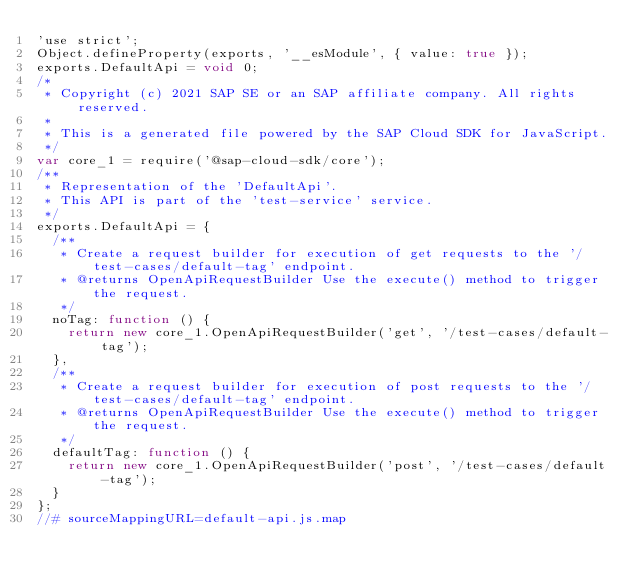Convert code to text. <code><loc_0><loc_0><loc_500><loc_500><_JavaScript_>'use strict';
Object.defineProperty(exports, '__esModule', { value: true });
exports.DefaultApi = void 0;
/*
 * Copyright (c) 2021 SAP SE or an SAP affiliate company. All rights reserved.
 *
 * This is a generated file powered by the SAP Cloud SDK for JavaScript.
 */
var core_1 = require('@sap-cloud-sdk/core');
/**
 * Representation of the 'DefaultApi'.
 * This API is part of the 'test-service' service.
 */
exports.DefaultApi = {
  /**
   * Create a request builder for execution of get requests to the '/test-cases/default-tag' endpoint.
   * @returns OpenApiRequestBuilder Use the execute() method to trigger the request.
   */
  noTag: function () {
    return new core_1.OpenApiRequestBuilder('get', '/test-cases/default-tag');
  },
  /**
   * Create a request builder for execution of post requests to the '/test-cases/default-tag' endpoint.
   * @returns OpenApiRequestBuilder Use the execute() method to trigger the request.
   */
  defaultTag: function () {
    return new core_1.OpenApiRequestBuilder('post', '/test-cases/default-tag');
  }
};
//# sourceMappingURL=default-api.js.map
</code> 